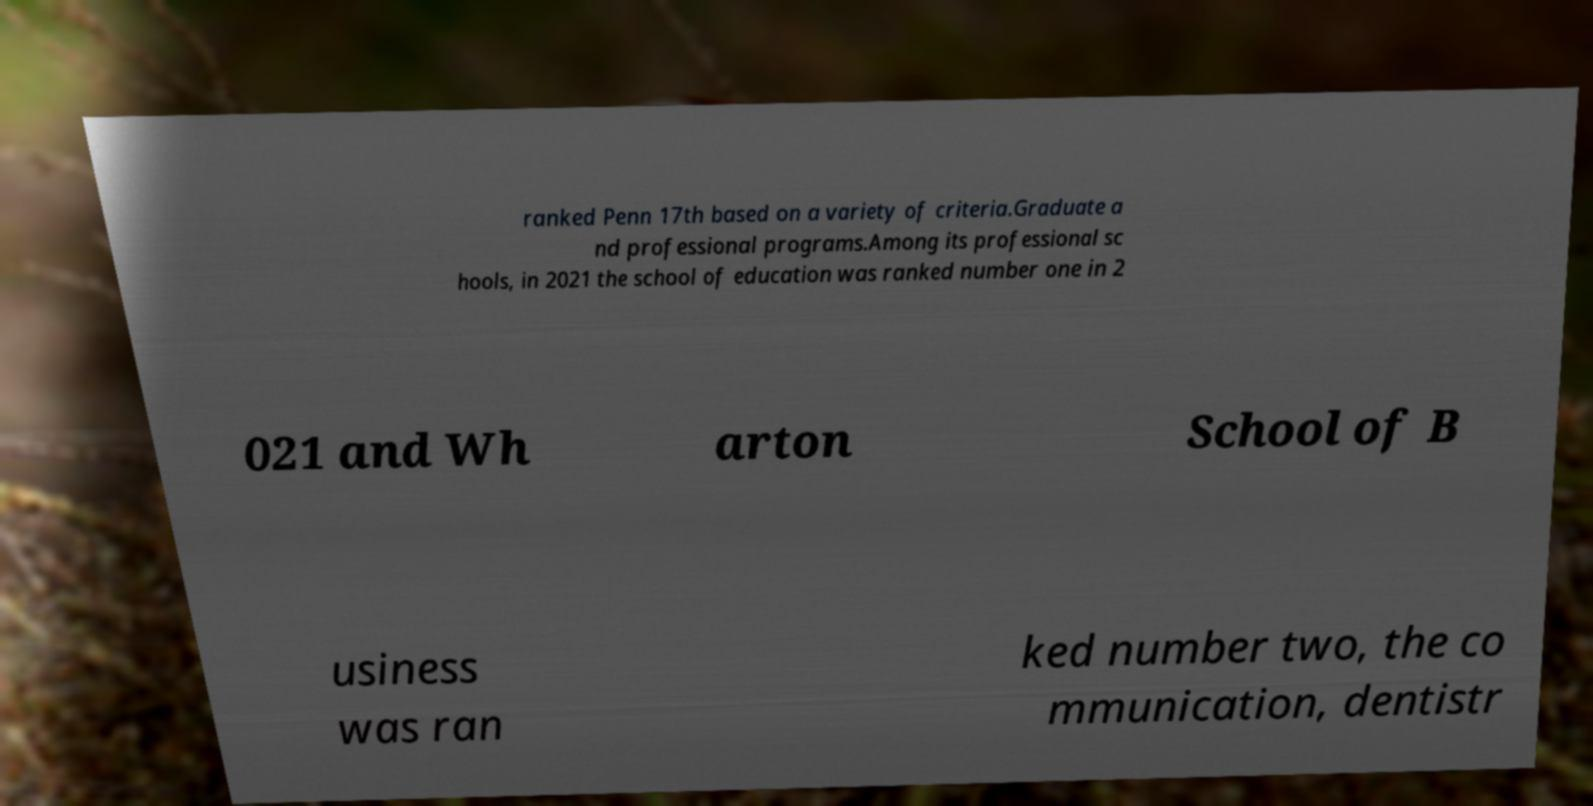Can you read and provide the text displayed in the image?This photo seems to have some interesting text. Can you extract and type it out for me? ranked Penn 17th based on a variety of criteria.Graduate a nd professional programs.Among its professional sc hools, in 2021 the school of education was ranked number one in 2 021 and Wh arton School of B usiness was ran ked number two, the co mmunication, dentistr 